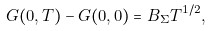<formula> <loc_0><loc_0><loc_500><loc_500>G ( 0 , T ) - G ( 0 , 0 ) = B _ { \Sigma } T ^ { 1 / 2 } ,</formula> 